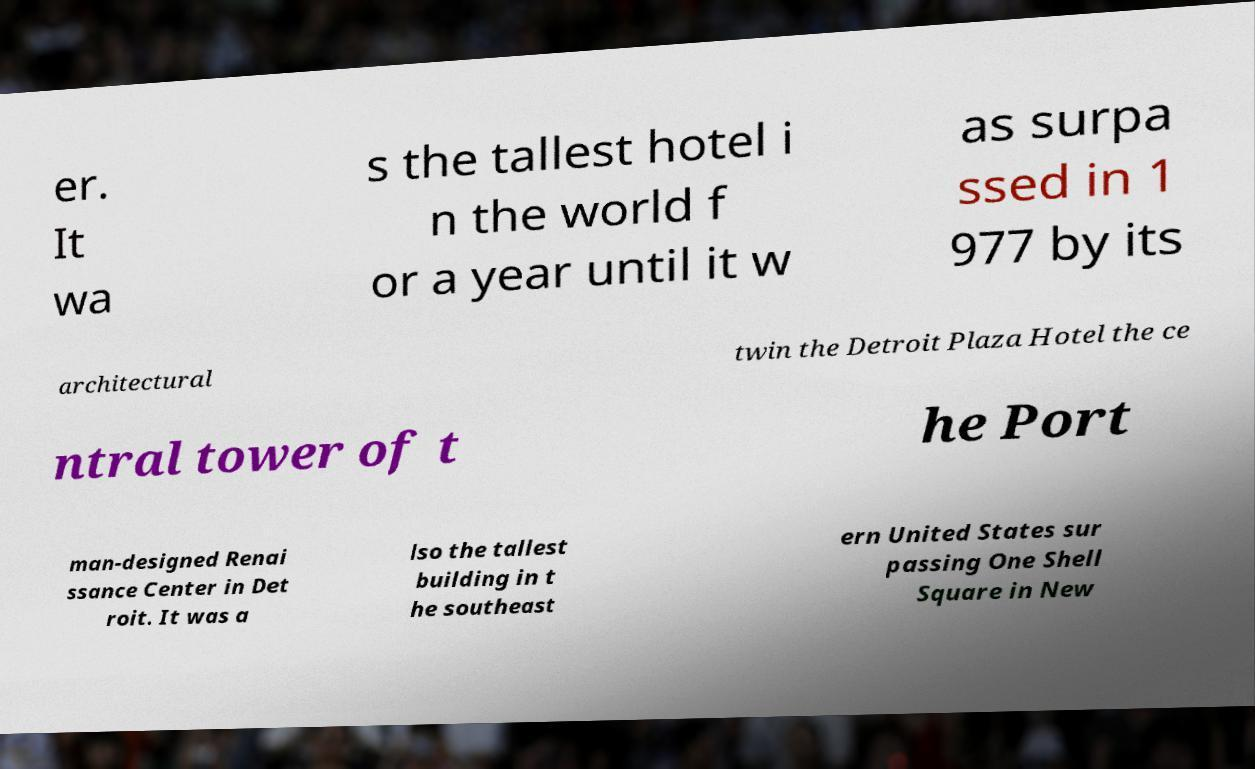I need the written content from this picture converted into text. Can you do that? er. It wa s the tallest hotel i n the world f or a year until it w as surpa ssed in 1 977 by its architectural twin the Detroit Plaza Hotel the ce ntral tower of t he Port man-designed Renai ssance Center in Det roit. It was a lso the tallest building in t he southeast ern United States sur passing One Shell Square in New 